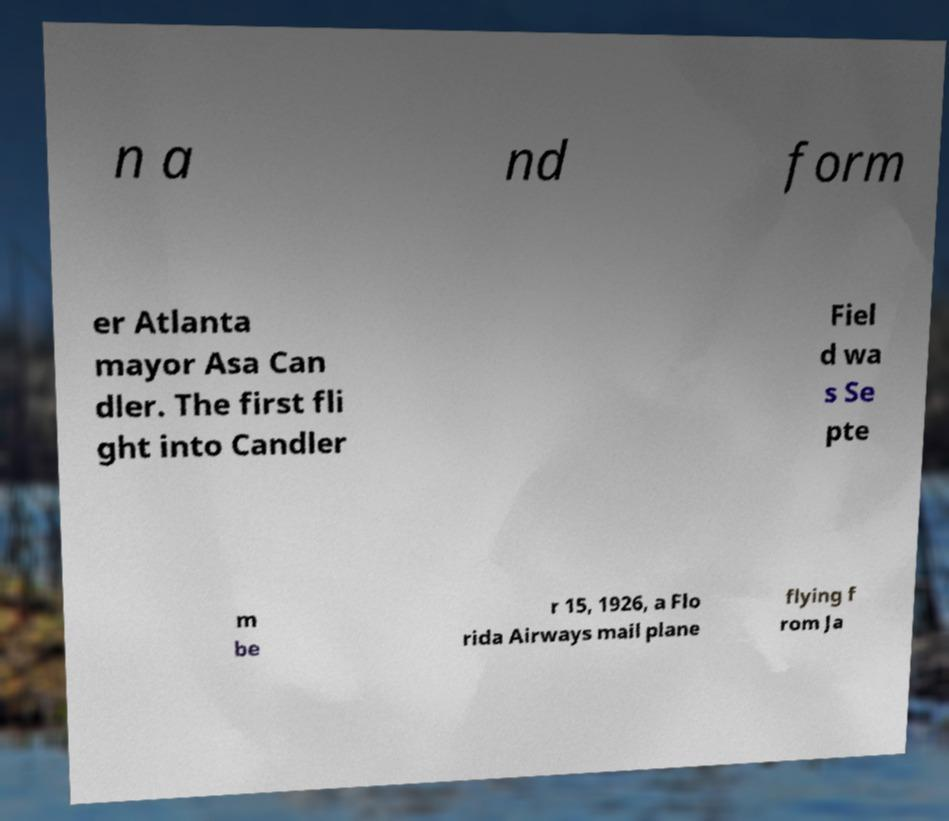There's text embedded in this image that I need extracted. Can you transcribe it verbatim? n a nd form er Atlanta mayor Asa Can dler. The first fli ght into Candler Fiel d wa s Se pte m be r 15, 1926, a Flo rida Airways mail plane flying f rom Ja 